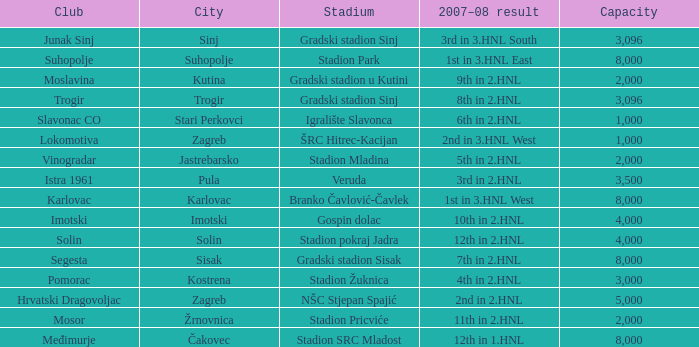What is the lowest capacity that has stadion mladina as the stadium? 2000.0. 